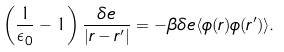Convert formula to latex. <formula><loc_0><loc_0><loc_500><loc_500>\left ( \frac { 1 } { \epsilon _ { 0 } } - 1 \right ) \frac { \delta e } { | { r } - { r } ^ { \prime } | } = - \beta \delta e \langle \phi ( { r } ) \phi ( { r } ^ { \prime } ) \rangle .</formula> 